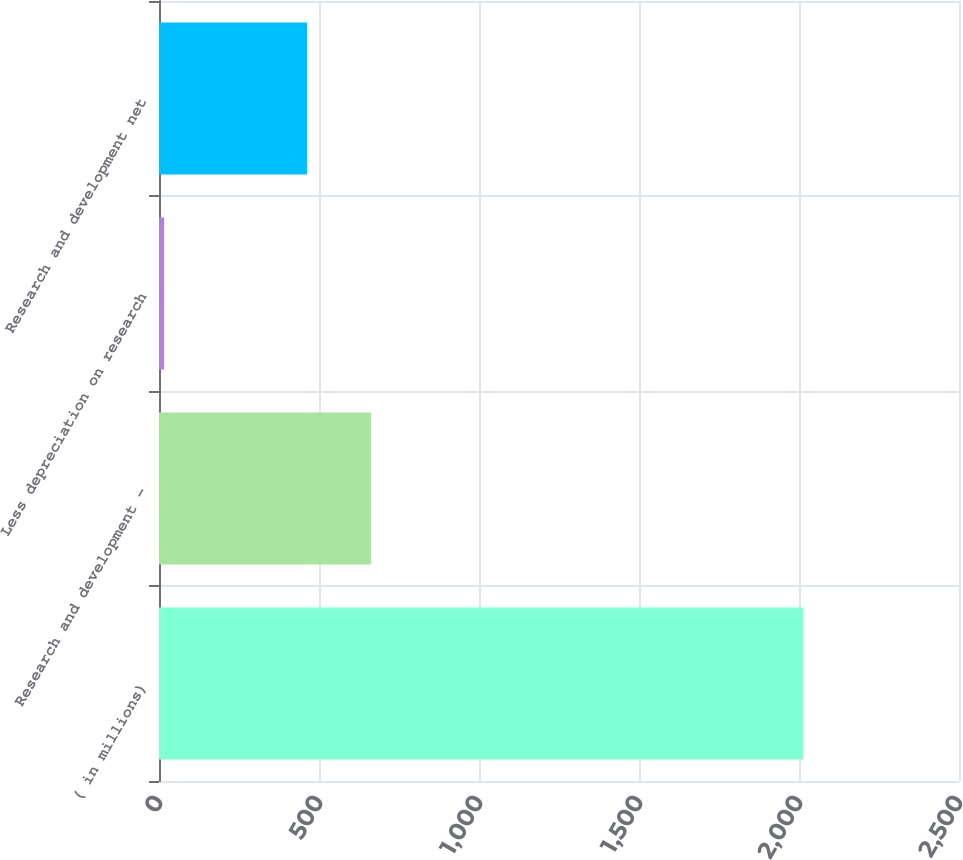Convert chart. <chart><loc_0><loc_0><loc_500><loc_500><bar_chart><fcel>( in millions)<fcel>Research and development -<fcel>Less depreciation on research<fcel>Research and development net<nl><fcel>2013<fcel>662.7<fcel>16<fcel>463<nl></chart> 